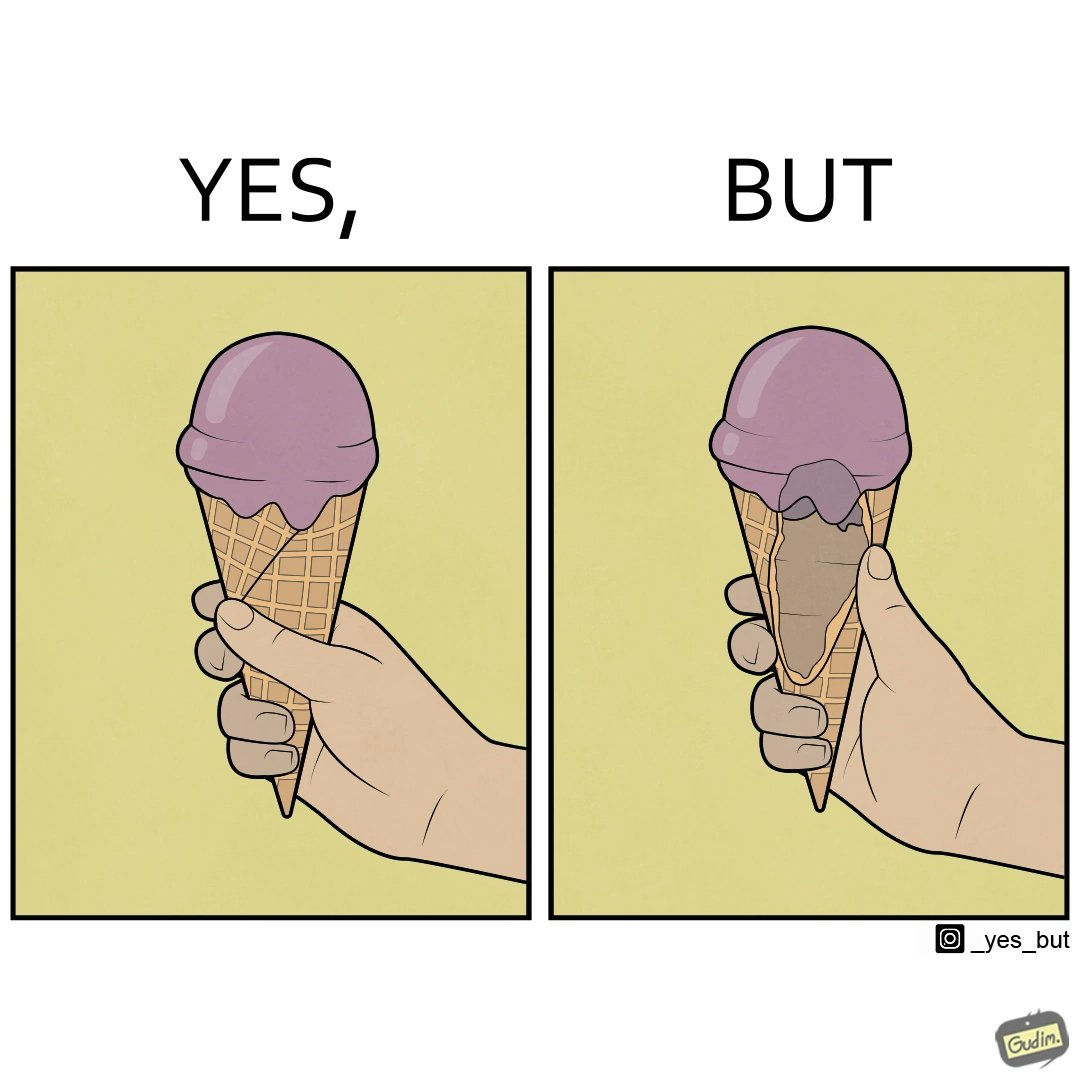What is shown in the left half versus the right half of this image? In the left part of the image: a softy cone filed with ice cream at top and probably melting from the sides because of more quantity than space In the right part of the image: an open section of softy cone showing only a limited softy is filled over the cone and the hollow part of ice cream is empty or vacant 